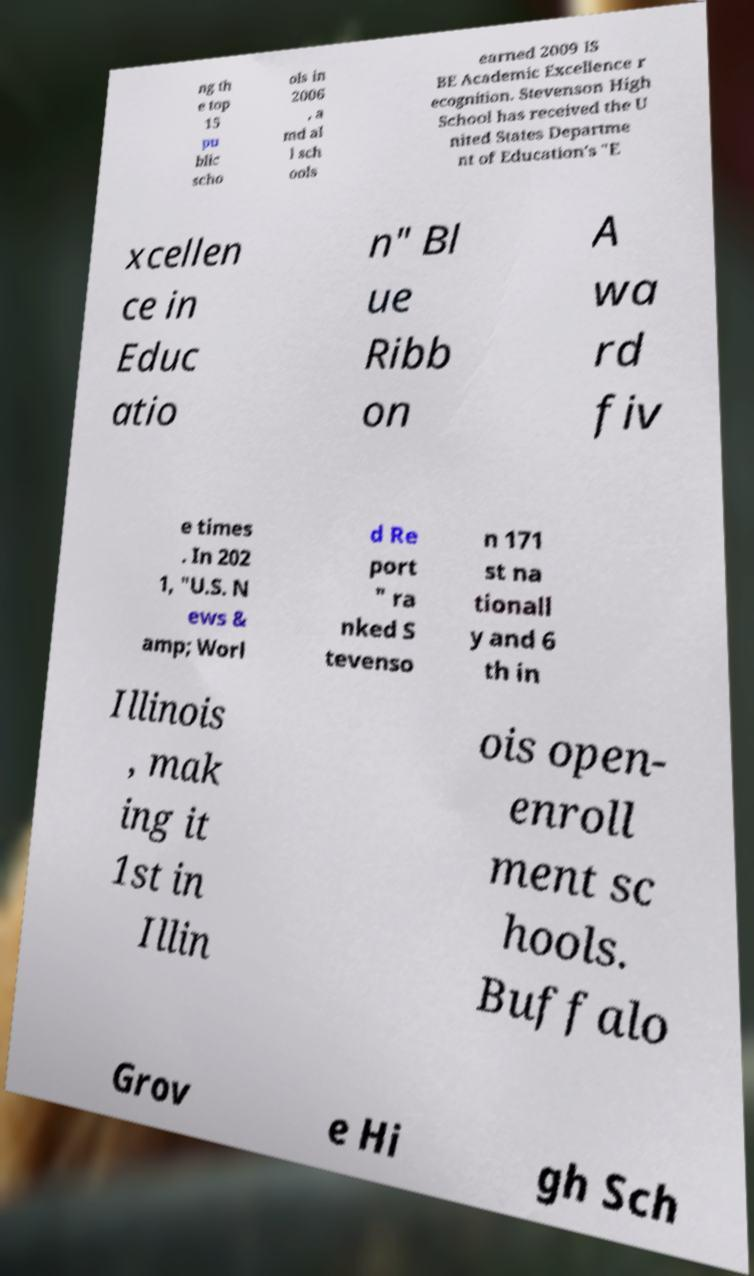Can you read and provide the text displayed in the image?This photo seems to have some interesting text. Can you extract and type it out for me? ng th e top 15 pu blic scho ols in 2006 , a md al l sch ools earned 2009 IS BE Academic Excellence r ecognition. Stevenson High School has received the U nited States Departme nt of Education's "E xcellen ce in Educ atio n" Bl ue Ribb on A wa rd fiv e times . In 202 1, "U.S. N ews & amp; Worl d Re port " ra nked S tevenso n 171 st na tionall y and 6 th in Illinois , mak ing it 1st in Illin ois open- enroll ment sc hools. Buffalo Grov e Hi gh Sch 